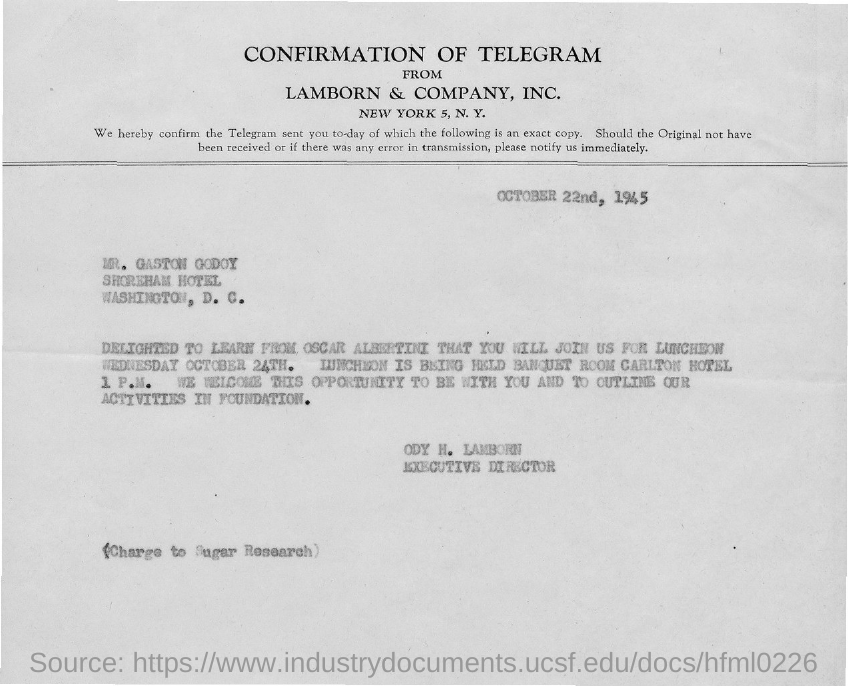Draw attention to some important aspects in this diagram. It was confirmed by Lamborn & Company, Inc., a company from which the sender received information. The document is addressed to Mr. Gaston Godoy. The luncheon is scheduled for 1 P.M... Oscar Albertini has stated that Mr. Gaston Godoy will be joining them for lunch. The luncheon will take place on Wednesday, October 24th. 